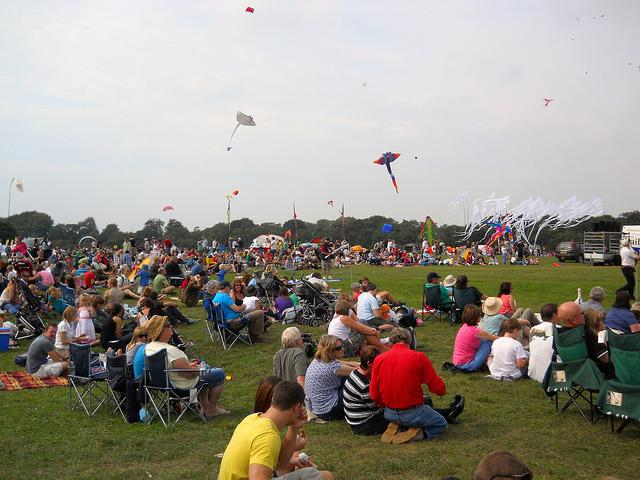Why are there more people than kites? Please explain your reasoning. mostly spectators. People like to watch events with kites. 